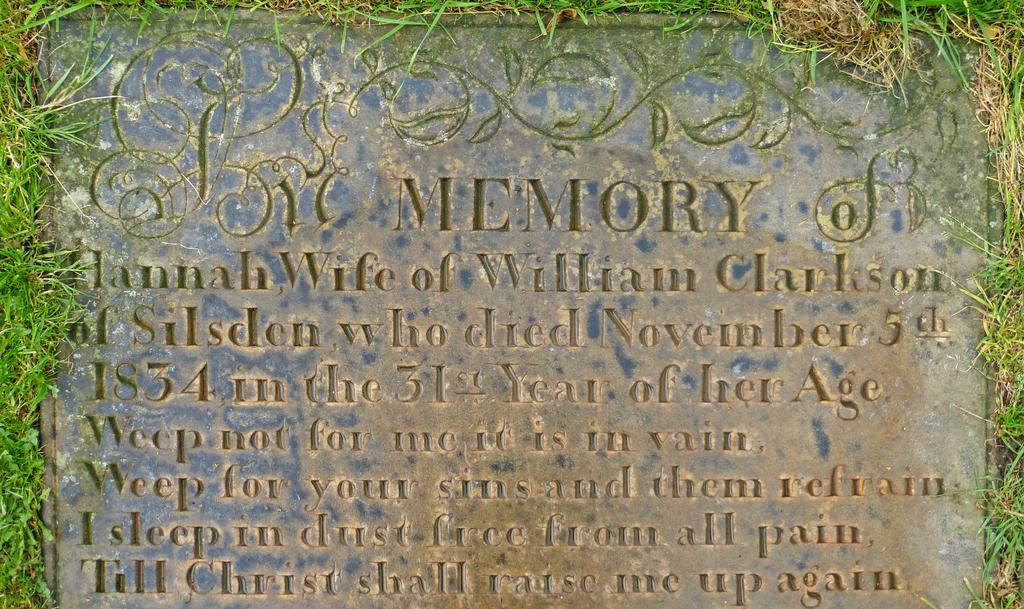What is the main subject of the image? There is a gravestone in the image. How many buttons are on the gravestone in the image? There are no buttons present on the gravestone in the image. What type of hair can be seen on the gravestone in the image? There is no hair present on the gravestone in the image. 